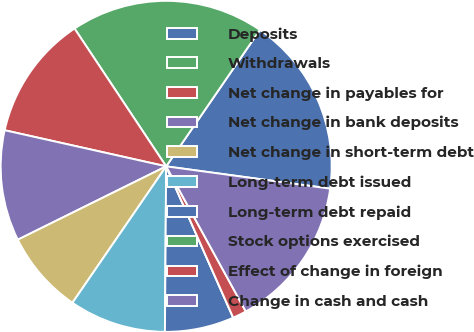Convert chart to OTSL. <chart><loc_0><loc_0><loc_500><loc_500><pie_chart><fcel>Deposits<fcel>Withdrawals<fcel>Net change in payables for<fcel>Net change in bank deposits<fcel>Net change in short-term debt<fcel>Long-term debt issued<fcel>Long-term debt repaid<fcel>Stock options exercised<fcel>Effect of change in foreign<fcel>Change in cash and cash<nl><fcel>17.57%<fcel>18.92%<fcel>12.16%<fcel>10.81%<fcel>8.11%<fcel>9.46%<fcel>6.76%<fcel>0.0%<fcel>1.35%<fcel>14.86%<nl></chart> 